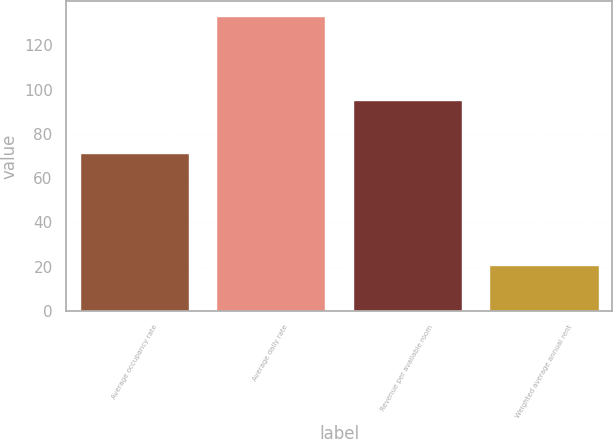Convert chart to OTSL. <chart><loc_0><loc_0><loc_500><loc_500><bar_chart><fcel>Average occupancy rate<fcel>Average daily rate<fcel>Revenue per available room<fcel>Weighted average annual rent<nl><fcel>71.5<fcel>133.2<fcel>95.18<fcel>20.54<nl></chart> 